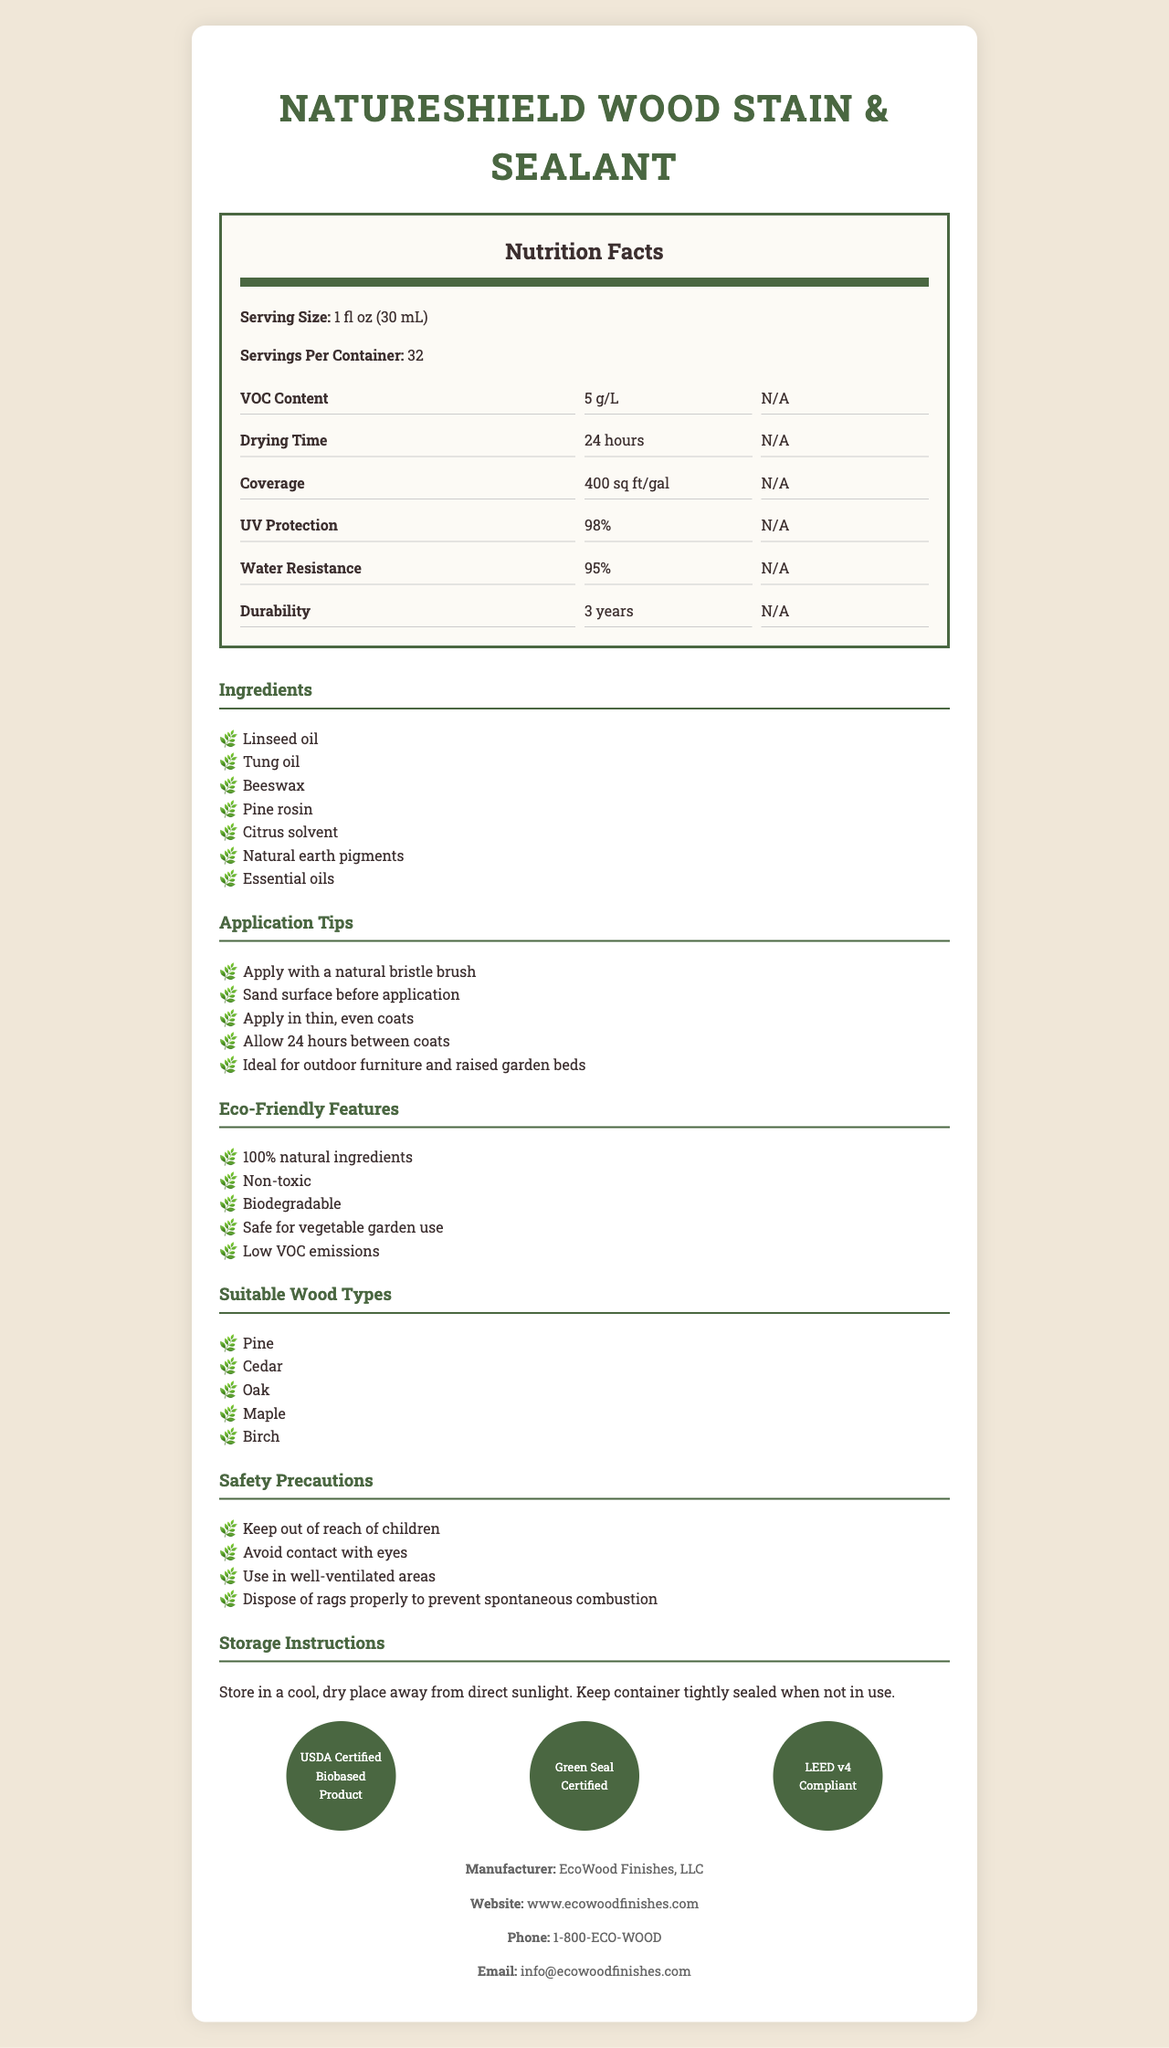What is the serving size for NatureShield Wood Stain & Sealant? The serving size is clearly mentioned at the beginning of the document under the Nutrition Facts section.
Answer: 1 fl oz (30 mL) How many servings are there per container? This information is listed right after the serving size in the Nutrition Facts section.
Answer: 32 What is the VOC content of NatureShield Wood Stain & Sealant? The VOC content is specified in the Nutrition Facts grid under the "VOC Content" row.
Answer: 5 g/L How long does it take for the stain to dry? The drying time can be found in the Nutrition Facts grid under "Drying Time".
Answer: 24 hours What is the coverage amount per gallon? Coverage information is located in the Nutrition Facts grid under "Coverage".
Answer: 400 sq ft/gal Which of the following is NOT listed as an ingredient? A. Linseed oil B. Beeswax C. Olive oil D. Tung oil Olive oil is not listed in the ingredients list in the document.
Answer: C What percentage of UV protection does the product offer? The percentage of UV protection is detailed in the Nutrition Facts section under "UV Protection".
Answer: 98% What kind of brush is recommended for applying this product? One of the application tips mentions applying the product with a natural bristle brush.
Answer: Natural bristle brush Is this wood stain and sealant biodegradable? Yes/No The document lists "Biodegradable" under the Eco-Friendly Features section.
Answer: Yes List three types of wood that are suitable for using this product. The Wood Types section mentions Pine, Cedar, Oak, Maple, and Birch.
Answer: Pine, Cedar, Oak What certifications does the product have? These certifications are listed towards the end of the document under the Certifications section.
Answer: USDA Certified Biobased Product, Green Seal Certified, LEED v4 Compliant How long does the durability of the product last? The durability is mentioned in the Nutrition Facts grid under "Durability".
Answer: 3 years Which wood types is NatureShield Wood Stain & Sealant compatible with? A. Pine B. Cedar C. Oak D. All of the above The document lists Pine, Cedar, Oak, Maple, and Birch as suitable wood types, so all of the above is correct.
Answer: D Can the product be used for vegetable garden beds? The Eco-Friendly Features section states that the product is safe for vegetable garden use.
Answer: Yes How should the product be stored? Storage instructions are provided towards the end of the document.
Answer: In a cool, dry place away from direct sunlight, with the container tightly sealed when not in use What are the contact details for the manufacturer EcoWood Finishes, LLC? This information is located in the footer of the document under the Manufacturer section.
Answer: Website: www.ecowoodfinishes.com, Phone: 1-800-ECO-WOOD, Email: info@ecowoodfinishes.com How many certifications does the product have? The document lists three certifications: USDA Certified Biobased Product, Green Seal Certified, and LEED v4 Compliant.
Answer: Three Is the product non-toxic? The document lists "Non-toxic" under the Eco-Friendly Features section.
Answer: Yes Which essential oils might be in the product? The document lists "Essential oils" as an ingredient but does not specify which types.
Answer: Cannot be determined Summarize the main features and uses of NatureShield Wood Stain & Sealant. This summary encompasses the document's primary points, including its eco-friendly properties, application tips, certification, suitable wood types, product features, and manufacturer information.
Answer: NatureShield Wood Stain & Sealant is a 100% natural, non-toxic, and biodegradable wood finishing product. It features low VOC emissions and is safe for use in vegetable gardens. It provides 98% UV protection, 95% water resistance, and has a durability of up to 3 years. It can be applied using a natural bristle brush in thin, even coats with 24-hour drying time between layers. It's suitable for various wood types, including pine, cedar, oak, maple, and birch. The product is certified by USDA as a Certified Biobased Product, Green Seal, and LEED v4. Storage requires a cool, dry place away from sunlight. The manufacturer is EcoWood Finishes, LLC. 